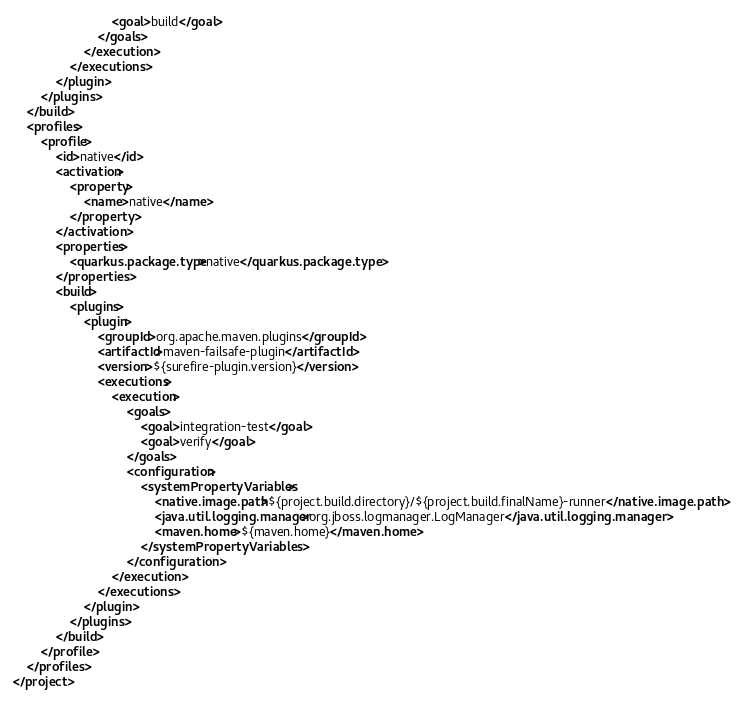<code> <loc_0><loc_0><loc_500><loc_500><_XML_>                            <goal>build</goal>
                        </goals>
                    </execution>
                </executions>
            </plugin>
        </plugins>
    </build>
    <profiles>
        <profile>
            <id>native</id>
            <activation>
                <property>
                    <name>native</name>
                </property>
            </activation>
            <properties>
                <quarkus.package.type>native</quarkus.package.type>
            </properties>
            <build>
                <plugins>
                    <plugin>
                        <groupId>org.apache.maven.plugins</groupId>
                        <artifactId>maven-failsafe-plugin</artifactId>
                        <version>${surefire-plugin.version}</version>
                        <executions>
                            <execution>
                                <goals>
                                    <goal>integration-test</goal>
                                    <goal>verify</goal>
                                </goals>
                                <configuration>
                                    <systemPropertyVariables>
                                        <native.image.path>${project.build.directory}/${project.build.finalName}-runner</native.image.path>
                                        <java.util.logging.manager>org.jboss.logmanager.LogManager</java.util.logging.manager>
                                        <maven.home>${maven.home}</maven.home>
                                    </systemPropertyVariables>
                                </configuration>
                            </execution>
                        </executions>
                    </plugin>
                </plugins>
            </build>
        </profile>
    </profiles>
</project>
</code> 